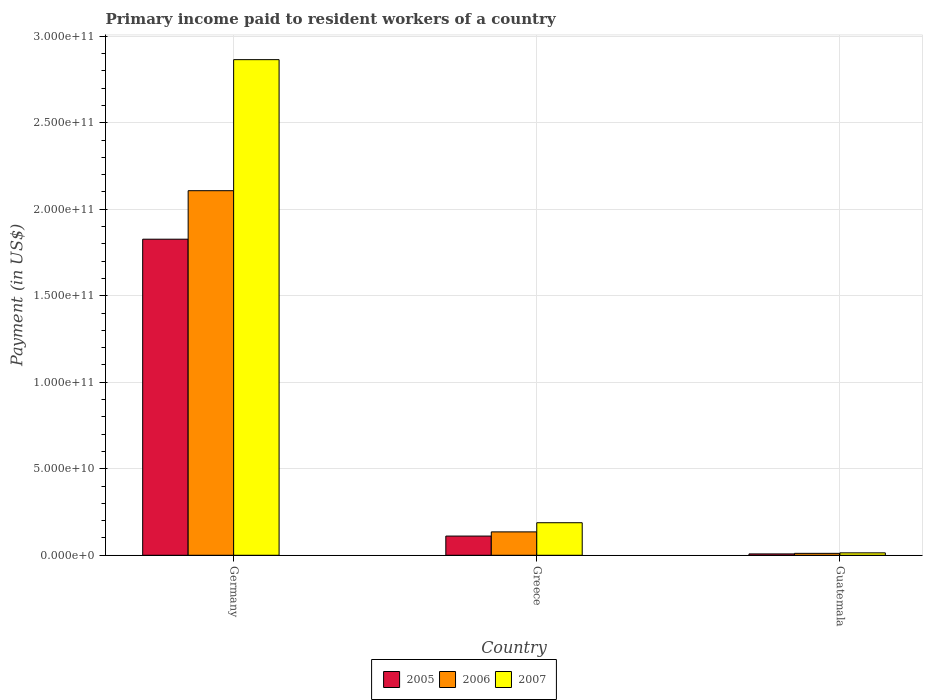Are the number of bars on each tick of the X-axis equal?
Your answer should be compact. Yes. How many bars are there on the 2nd tick from the right?
Make the answer very short. 3. What is the label of the 2nd group of bars from the left?
Your answer should be very brief. Greece. What is the amount paid to workers in 2007 in Greece?
Give a very brief answer. 1.88e+1. Across all countries, what is the maximum amount paid to workers in 2006?
Give a very brief answer. 2.11e+11. Across all countries, what is the minimum amount paid to workers in 2007?
Your answer should be very brief. 1.40e+09. In which country was the amount paid to workers in 2007 minimum?
Keep it short and to the point. Guatemala. What is the total amount paid to workers in 2006 in the graph?
Offer a terse response. 2.25e+11. What is the difference between the amount paid to workers in 2007 in Germany and that in Guatemala?
Your response must be concise. 2.85e+11. What is the difference between the amount paid to workers in 2005 in Germany and the amount paid to workers in 2007 in Guatemala?
Give a very brief answer. 1.81e+11. What is the average amount paid to workers in 2005 per country?
Your answer should be compact. 6.49e+1. What is the difference between the amount paid to workers of/in 2005 and amount paid to workers of/in 2006 in Germany?
Your answer should be very brief. -2.80e+1. What is the ratio of the amount paid to workers in 2007 in Germany to that in Guatemala?
Offer a terse response. 204.8. Is the amount paid to workers in 2007 in Greece less than that in Guatemala?
Offer a terse response. No. Is the difference between the amount paid to workers in 2005 in Germany and Guatemala greater than the difference between the amount paid to workers in 2006 in Germany and Guatemala?
Keep it short and to the point. No. What is the difference between the highest and the second highest amount paid to workers in 2006?
Provide a succinct answer. 1.97e+11. What is the difference between the highest and the lowest amount paid to workers in 2007?
Your answer should be very brief. 2.85e+11. In how many countries, is the amount paid to workers in 2007 greater than the average amount paid to workers in 2007 taken over all countries?
Make the answer very short. 1. How many bars are there?
Offer a very short reply. 9. How many countries are there in the graph?
Make the answer very short. 3. Are the values on the major ticks of Y-axis written in scientific E-notation?
Provide a short and direct response. Yes. Does the graph contain grids?
Keep it short and to the point. Yes. Where does the legend appear in the graph?
Keep it short and to the point. Bottom center. How many legend labels are there?
Offer a very short reply. 3. What is the title of the graph?
Your answer should be compact. Primary income paid to resident workers of a country. What is the label or title of the Y-axis?
Your response must be concise. Payment (in US$). What is the Payment (in US$) in 2005 in Germany?
Your answer should be compact. 1.83e+11. What is the Payment (in US$) in 2006 in Germany?
Your answer should be compact. 2.11e+11. What is the Payment (in US$) of 2007 in Germany?
Your answer should be compact. 2.86e+11. What is the Payment (in US$) in 2005 in Greece?
Give a very brief answer. 1.11e+1. What is the Payment (in US$) of 2006 in Greece?
Offer a terse response. 1.35e+1. What is the Payment (in US$) of 2007 in Greece?
Your response must be concise. 1.88e+1. What is the Payment (in US$) of 2005 in Guatemala?
Provide a succinct answer. 7.86e+08. What is the Payment (in US$) in 2006 in Guatemala?
Make the answer very short. 1.12e+09. What is the Payment (in US$) in 2007 in Guatemala?
Your answer should be compact. 1.40e+09. Across all countries, what is the maximum Payment (in US$) of 2005?
Offer a terse response. 1.83e+11. Across all countries, what is the maximum Payment (in US$) of 2006?
Provide a short and direct response. 2.11e+11. Across all countries, what is the maximum Payment (in US$) in 2007?
Give a very brief answer. 2.86e+11. Across all countries, what is the minimum Payment (in US$) of 2005?
Keep it short and to the point. 7.86e+08. Across all countries, what is the minimum Payment (in US$) in 2006?
Offer a very short reply. 1.12e+09. Across all countries, what is the minimum Payment (in US$) of 2007?
Give a very brief answer. 1.40e+09. What is the total Payment (in US$) in 2005 in the graph?
Your answer should be very brief. 1.95e+11. What is the total Payment (in US$) of 2006 in the graph?
Your answer should be very brief. 2.25e+11. What is the total Payment (in US$) in 2007 in the graph?
Offer a very short reply. 3.07e+11. What is the difference between the Payment (in US$) in 2005 in Germany and that in Greece?
Your answer should be very brief. 1.72e+11. What is the difference between the Payment (in US$) in 2006 in Germany and that in Greece?
Your answer should be very brief. 1.97e+11. What is the difference between the Payment (in US$) of 2007 in Germany and that in Greece?
Ensure brevity in your answer.  2.68e+11. What is the difference between the Payment (in US$) in 2005 in Germany and that in Guatemala?
Give a very brief answer. 1.82e+11. What is the difference between the Payment (in US$) in 2006 in Germany and that in Guatemala?
Your answer should be very brief. 2.10e+11. What is the difference between the Payment (in US$) in 2007 in Germany and that in Guatemala?
Your answer should be very brief. 2.85e+11. What is the difference between the Payment (in US$) in 2005 in Greece and that in Guatemala?
Your answer should be very brief. 1.03e+1. What is the difference between the Payment (in US$) of 2006 in Greece and that in Guatemala?
Provide a succinct answer. 1.24e+1. What is the difference between the Payment (in US$) of 2007 in Greece and that in Guatemala?
Keep it short and to the point. 1.74e+1. What is the difference between the Payment (in US$) in 2005 in Germany and the Payment (in US$) in 2006 in Greece?
Provide a succinct answer. 1.69e+11. What is the difference between the Payment (in US$) in 2005 in Germany and the Payment (in US$) in 2007 in Greece?
Offer a terse response. 1.64e+11. What is the difference between the Payment (in US$) of 2006 in Germany and the Payment (in US$) of 2007 in Greece?
Your answer should be compact. 1.92e+11. What is the difference between the Payment (in US$) of 2005 in Germany and the Payment (in US$) of 2006 in Guatemala?
Offer a very short reply. 1.82e+11. What is the difference between the Payment (in US$) of 2005 in Germany and the Payment (in US$) of 2007 in Guatemala?
Your response must be concise. 1.81e+11. What is the difference between the Payment (in US$) of 2006 in Germany and the Payment (in US$) of 2007 in Guatemala?
Offer a very short reply. 2.09e+11. What is the difference between the Payment (in US$) in 2005 in Greece and the Payment (in US$) in 2006 in Guatemala?
Make the answer very short. 9.99e+09. What is the difference between the Payment (in US$) of 2005 in Greece and the Payment (in US$) of 2007 in Guatemala?
Keep it short and to the point. 9.70e+09. What is the difference between the Payment (in US$) of 2006 in Greece and the Payment (in US$) of 2007 in Guatemala?
Provide a short and direct response. 1.21e+1. What is the average Payment (in US$) in 2005 per country?
Keep it short and to the point. 6.49e+1. What is the average Payment (in US$) of 2006 per country?
Provide a succinct answer. 7.51e+1. What is the average Payment (in US$) of 2007 per country?
Provide a succinct answer. 1.02e+11. What is the difference between the Payment (in US$) in 2005 and Payment (in US$) in 2006 in Germany?
Provide a short and direct response. -2.80e+1. What is the difference between the Payment (in US$) of 2005 and Payment (in US$) of 2007 in Germany?
Keep it short and to the point. -1.04e+11. What is the difference between the Payment (in US$) in 2006 and Payment (in US$) in 2007 in Germany?
Provide a short and direct response. -7.57e+1. What is the difference between the Payment (in US$) of 2005 and Payment (in US$) of 2006 in Greece?
Give a very brief answer. -2.42e+09. What is the difference between the Payment (in US$) of 2005 and Payment (in US$) of 2007 in Greece?
Offer a terse response. -7.71e+09. What is the difference between the Payment (in US$) in 2006 and Payment (in US$) in 2007 in Greece?
Your answer should be compact. -5.29e+09. What is the difference between the Payment (in US$) of 2005 and Payment (in US$) of 2006 in Guatemala?
Offer a very short reply. -3.28e+08. What is the difference between the Payment (in US$) of 2005 and Payment (in US$) of 2007 in Guatemala?
Provide a short and direct response. -6.12e+08. What is the difference between the Payment (in US$) of 2006 and Payment (in US$) of 2007 in Guatemala?
Ensure brevity in your answer.  -2.84e+08. What is the ratio of the Payment (in US$) in 2005 in Germany to that in Greece?
Keep it short and to the point. 16.46. What is the ratio of the Payment (in US$) of 2006 in Germany to that in Greece?
Provide a succinct answer. 15.58. What is the ratio of the Payment (in US$) of 2007 in Germany to that in Greece?
Offer a terse response. 15.23. What is the ratio of the Payment (in US$) of 2005 in Germany to that in Guatemala?
Provide a short and direct response. 232.27. What is the ratio of the Payment (in US$) of 2006 in Germany to that in Guatemala?
Make the answer very short. 188.98. What is the ratio of the Payment (in US$) of 2007 in Germany to that in Guatemala?
Offer a very short reply. 204.8. What is the ratio of the Payment (in US$) of 2005 in Greece to that in Guatemala?
Your answer should be very brief. 14.12. What is the ratio of the Payment (in US$) of 2006 in Greece to that in Guatemala?
Keep it short and to the point. 12.13. What is the ratio of the Payment (in US$) of 2007 in Greece to that in Guatemala?
Ensure brevity in your answer.  13.45. What is the difference between the highest and the second highest Payment (in US$) of 2005?
Your answer should be compact. 1.72e+11. What is the difference between the highest and the second highest Payment (in US$) of 2006?
Your response must be concise. 1.97e+11. What is the difference between the highest and the second highest Payment (in US$) in 2007?
Provide a short and direct response. 2.68e+11. What is the difference between the highest and the lowest Payment (in US$) of 2005?
Provide a succinct answer. 1.82e+11. What is the difference between the highest and the lowest Payment (in US$) in 2006?
Provide a short and direct response. 2.10e+11. What is the difference between the highest and the lowest Payment (in US$) of 2007?
Offer a terse response. 2.85e+11. 